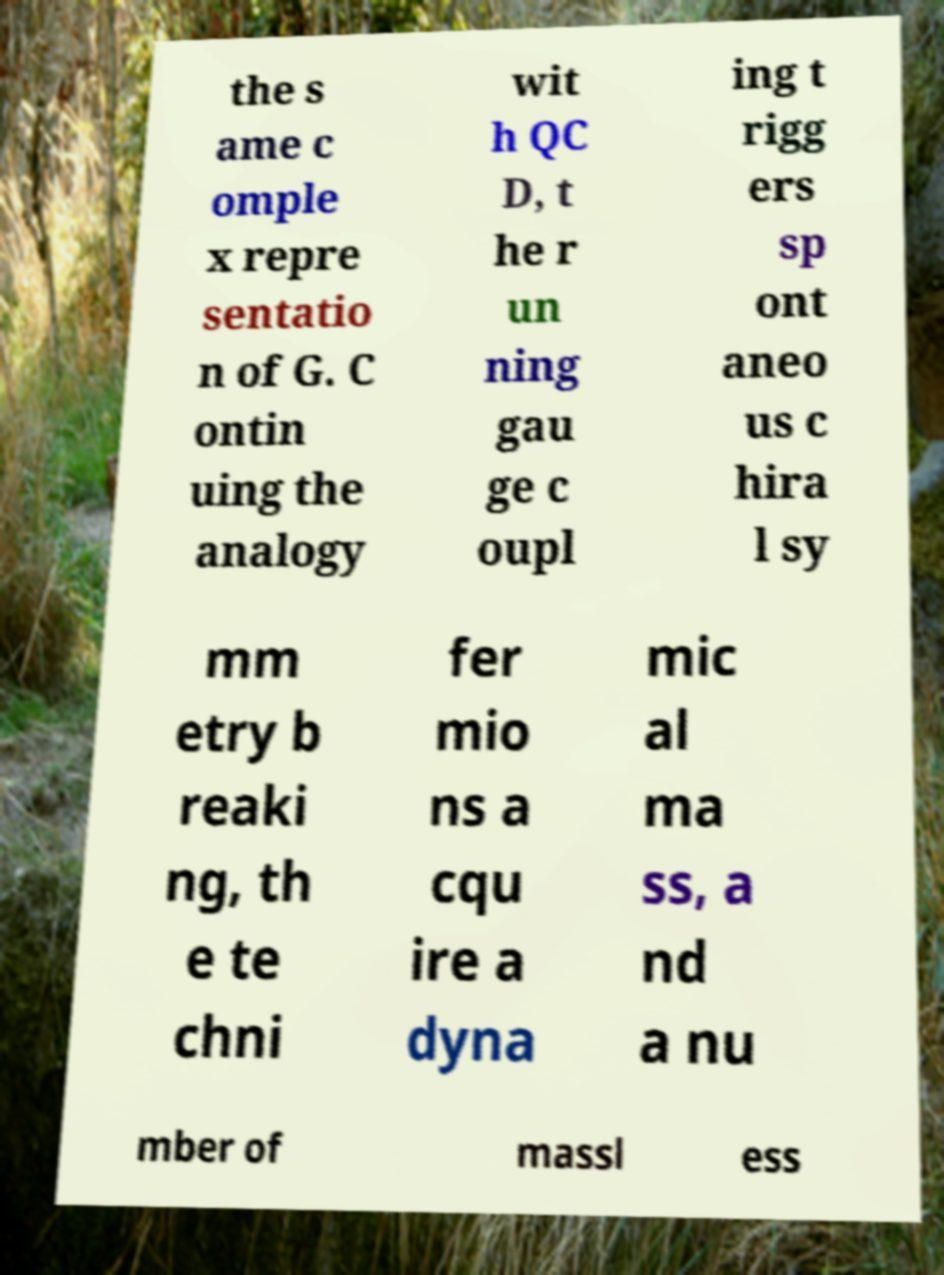I need the written content from this picture converted into text. Can you do that? the s ame c omple x repre sentatio n of G. C ontin uing the analogy wit h QC D, t he r un ning gau ge c oupl ing t rigg ers sp ont aneo us c hira l sy mm etry b reaki ng, th e te chni fer mio ns a cqu ire a dyna mic al ma ss, a nd a nu mber of massl ess 